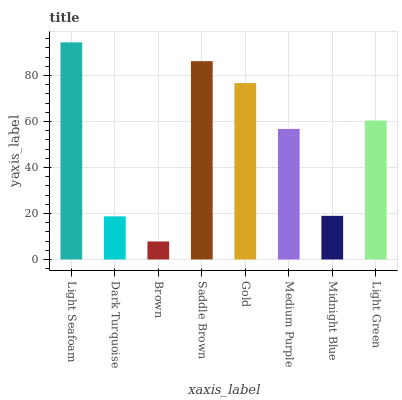Is Brown the minimum?
Answer yes or no. Yes. Is Light Seafoam the maximum?
Answer yes or no. Yes. Is Dark Turquoise the minimum?
Answer yes or no. No. Is Dark Turquoise the maximum?
Answer yes or no. No. Is Light Seafoam greater than Dark Turquoise?
Answer yes or no. Yes. Is Dark Turquoise less than Light Seafoam?
Answer yes or no. Yes. Is Dark Turquoise greater than Light Seafoam?
Answer yes or no. No. Is Light Seafoam less than Dark Turquoise?
Answer yes or no. No. Is Light Green the high median?
Answer yes or no. Yes. Is Medium Purple the low median?
Answer yes or no. Yes. Is Gold the high median?
Answer yes or no. No. Is Dark Turquoise the low median?
Answer yes or no. No. 